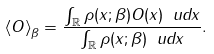<formula> <loc_0><loc_0><loc_500><loc_500>\left \langle O \right \rangle _ { \beta } = \frac { \int _ { \mathbb { R } } \rho ( x ; \beta ) O ( x ) \ u d x } { \int _ { \mathbb { R } } \rho ( x ; \beta ) \ u d x } .</formula> 